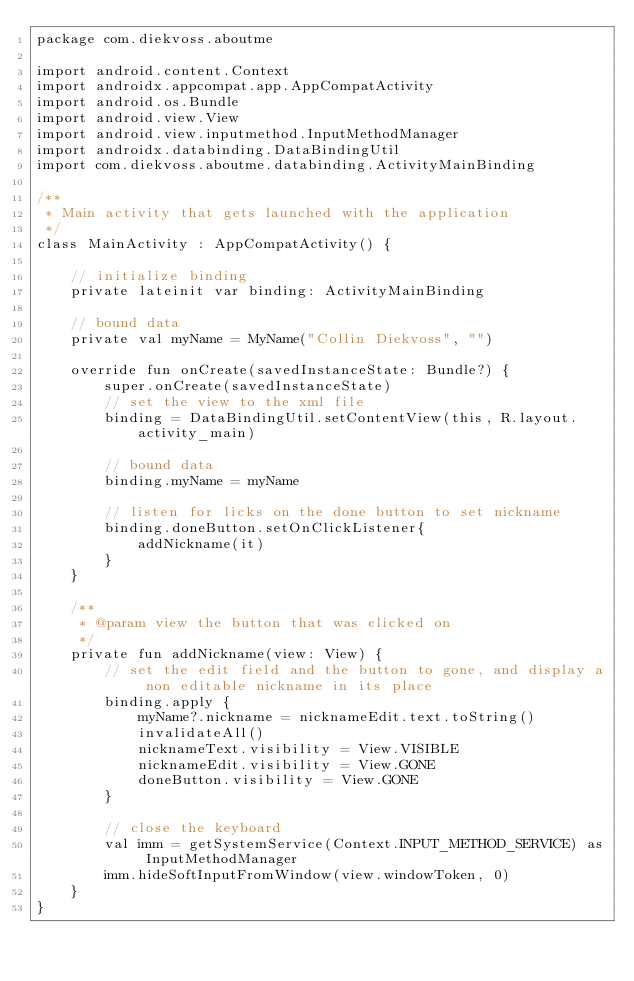Convert code to text. <code><loc_0><loc_0><loc_500><loc_500><_Kotlin_>package com.diekvoss.aboutme

import android.content.Context
import androidx.appcompat.app.AppCompatActivity
import android.os.Bundle
import android.view.View
import android.view.inputmethod.InputMethodManager
import androidx.databinding.DataBindingUtil
import com.diekvoss.aboutme.databinding.ActivityMainBinding

/**
 * Main activity that gets launched with the application
 */
class MainActivity : AppCompatActivity() {

    // initialize binding
    private lateinit var binding: ActivityMainBinding

    // bound data
    private val myName = MyName("Collin Diekvoss", "")

    override fun onCreate(savedInstanceState: Bundle?) {
        super.onCreate(savedInstanceState)
        // set the view to the xml file
        binding = DataBindingUtil.setContentView(this, R.layout.activity_main)

        // bound data
        binding.myName = myName

        // listen for licks on the done button to set nickname
        binding.doneButton.setOnClickListener{
            addNickname(it)
        }
    }

    /**
     * @param view the button that was clicked on
     */
    private fun addNickname(view: View) {
        // set the edit field and the button to gone, and display a non editable nickname in its place
        binding.apply {
            myName?.nickname = nicknameEdit.text.toString()
            invalidateAll()
            nicknameText.visibility = View.VISIBLE
            nicknameEdit.visibility = View.GONE
            doneButton.visibility = View.GONE
        }

        // close the keyboard
        val imm = getSystemService(Context.INPUT_METHOD_SERVICE) as InputMethodManager
        imm.hideSoftInputFromWindow(view.windowToken, 0)
    }
}
</code> 